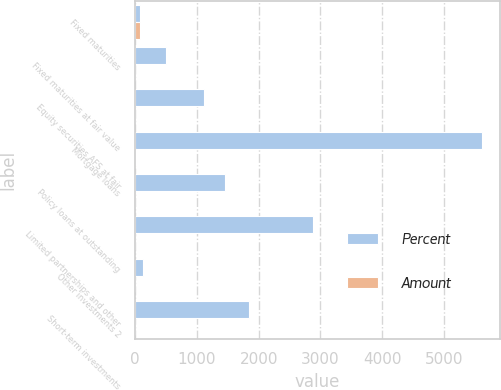Convert chart to OTSL. <chart><loc_0><loc_0><loc_500><loc_500><stacked_bar_chart><ecel><fcel>Fixed maturities<fcel>Fixed maturities at fair value<fcel>Equity securities AFS at fair<fcel>Mortgage loans<fcel>Policy loans at outstanding<fcel>Limited partnerships and other<fcel>Other investments 2<fcel>Short-term investments<nl><fcel>Percent<fcel>81.4<fcel>503<fcel>1121<fcel>5624<fcel>1447<fcel>2874<fcel>120<fcel>1843<nl><fcel>Amount<fcel>81.4<fcel>0.7<fcel>1.5<fcel>7.7<fcel>2<fcel>4<fcel>0.2<fcel>2.5<nl></chart> 